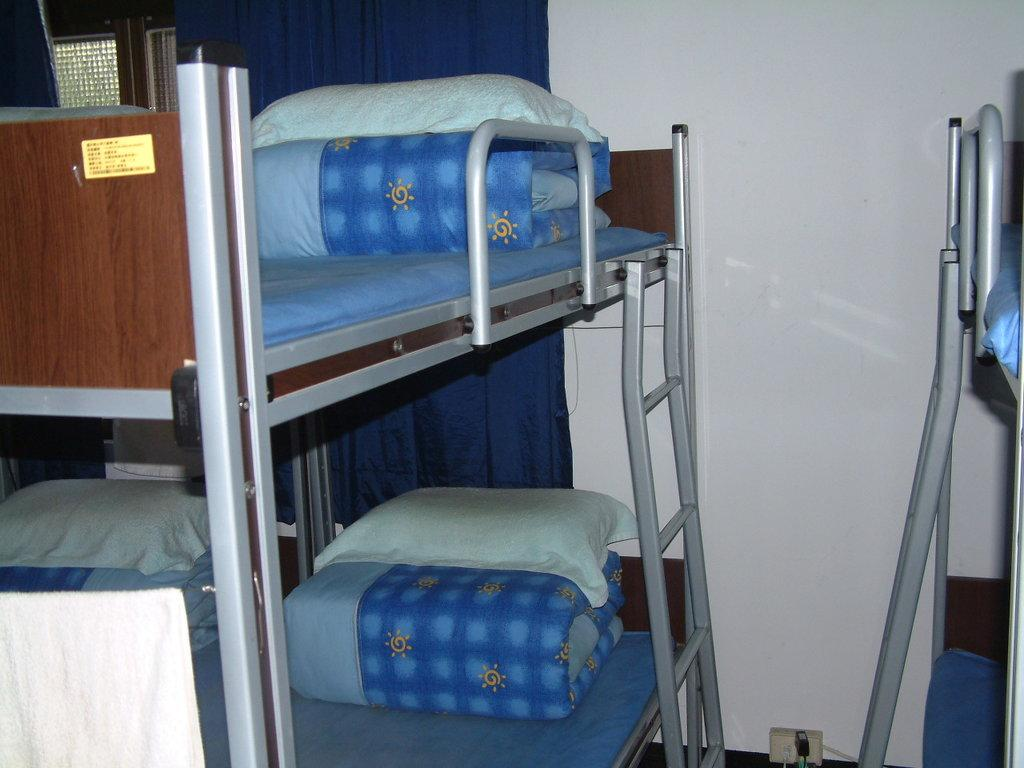What type of furniture is in the image? There are double bunk beds in the image. What items are used for comfort while sleeping? Pillows are visible in the image, and blankets are present in the image. What type of window treatment is in the image? There is a curtain in the image. What type of wound can be seen on the curtain in the image? There is no wound present on the curtain in the image. 